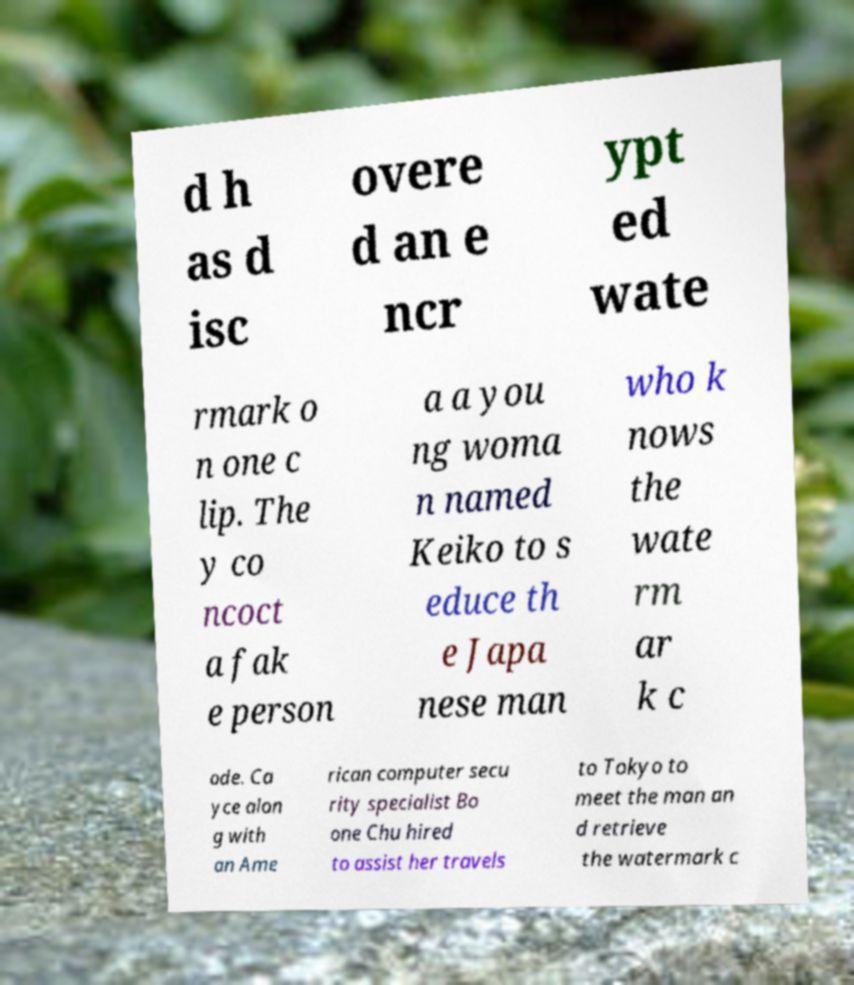Could you extract and type out the text from this image? d h as d isc overe d an e ncr ypt ed wate rmark o n one c lip. The y co ncoct a fak e person a a you ng woma n named Keiko to s educe th e Japa nese man who k nows the wate rm ar k c ode. Ca yce alon g with an Ame rican computer secu rity specialist Bo one Chu hired to assist her travels to Tokyo to meet the man an d retrieve the watermark c 